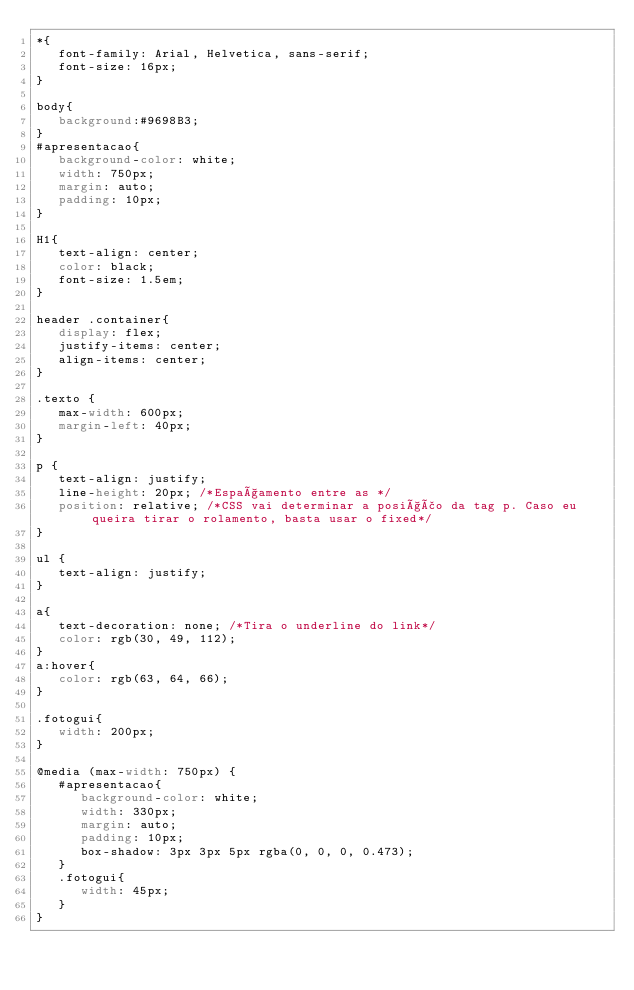Convert code to text. <code><loc_0><loc_0><loc_500><loc_500><_CSS_>*{
   font-family: Arial, Helvetica, sans-serif;
   font-size: 16px;
}

body{
   background:#9698B3;
}
#apresentacao{
   background-color: white;
   width: 750px;
   margin: auto;
   padding: 10px;
}

H1{
   text-align: center;
   color: black;
   font-size: 1.5em;
}

header .container{
   display: flex;
   justify-items: center;
   align-items: center;
}

.texto {
   max-width: 600px;
   margin-left: 40px;
}

p {
   text-align: justify;
   line-height: 20px; /*Espaçamento entre as */
   position: relative; /*CSS vai determinar a posição da tag p. Caso eu queira tirar o rolamento, basta usar o fixed*/
}

ul {
   text-align: justify;
}

a{
   text-decoration: none; /*Tira o underline do link*/
   color: rgb(30, 49, 112);
}
a:hover{
   color: rgb(63, 64, 66);
}

.fotogui{
   width: 200px;
}

@media (max-width: 750px) {
   #apresentacao{
      background-color: white;
      width: 330px;
      margin: auto;
      padding: 10px;
      box-shadow: 3px 3px 5px rgba(0, 0, 0, 0.473);
   } 
   .fotogui{
      width: 45px;
   }
}</code> 